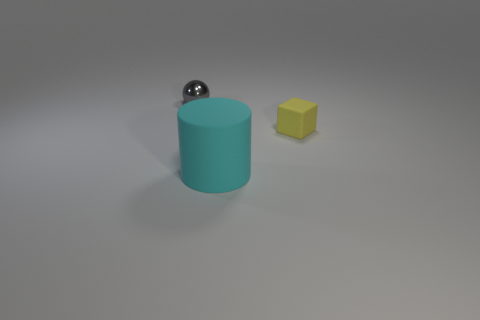Add 2 small yellow rubber objects. How many objects exist? 5 Subtract all cubes. How many objects are left? 2 Subtract 0 gray cylinders. How many objects are left? 3 Subtract all big rubber cubes. Subtract all rubber things. How many objects are left? 1 Add 2 large cylinders. How many large cylinders are left? 3 Add 1 purple rubber blocks. How many purple rubber blocks exist? 1 